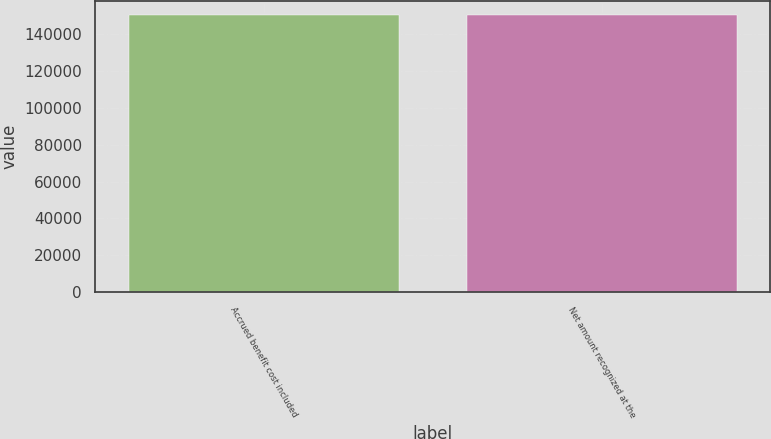Convert chart. <chart><loc_0><loc_0><loc_500><loc_500><bar_chart><fcel>Accrued benefit cost included<fcel>Net amount recognized at the<nl><fcel>150257<fcel>150257<nl></chart> 